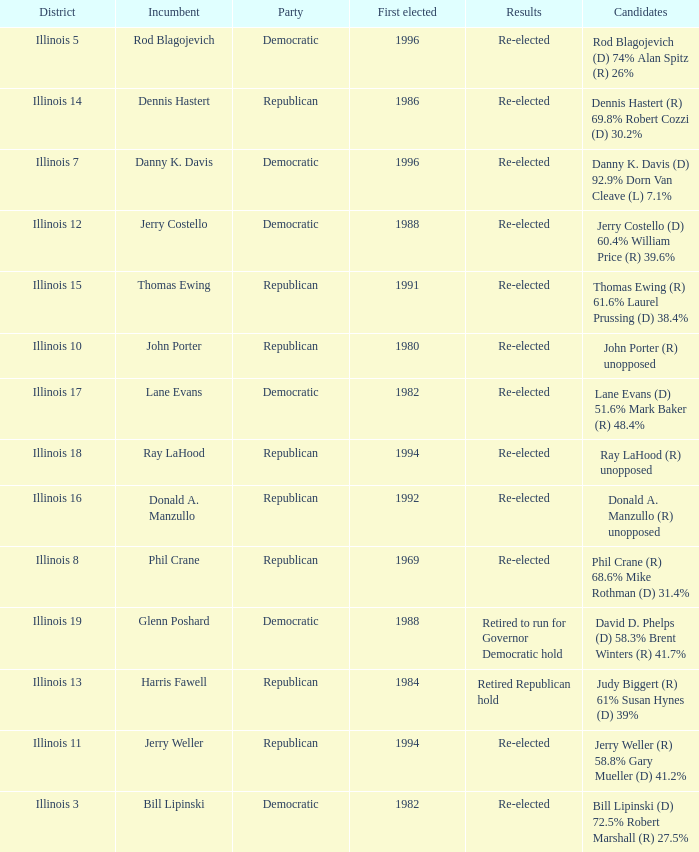Who were the candidates in the district where Jerry Costello won? Jerry Costello (D) 60.4% William Price (R) 39.6%. 